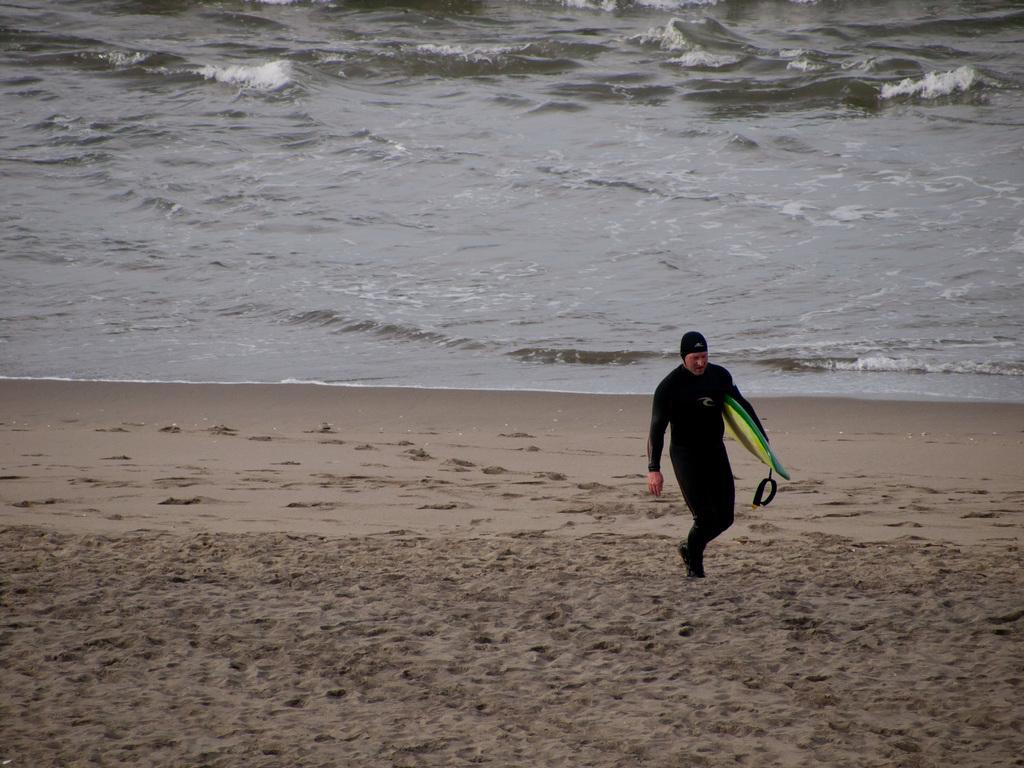Could you give a brief overview of what you see in this image? In this picture there is a man who is wearing black dress and holding skateboard. He is standing on the beach. At the top we can see the water. 